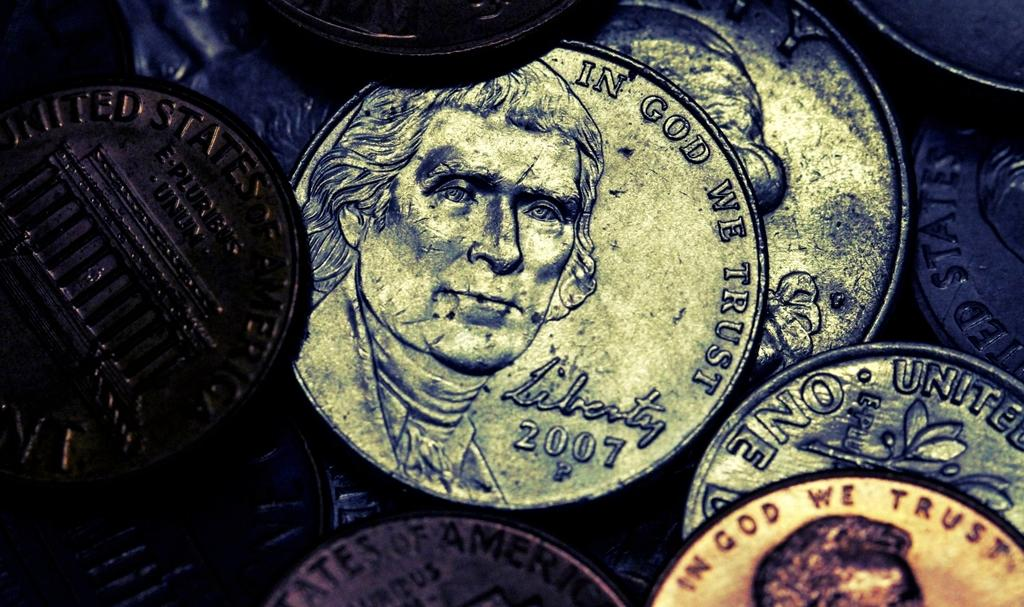<image>
Present a compact description of the photo's key features. A 2007 nickel depicting Thomas Jefferson and the motto In God We Trust 